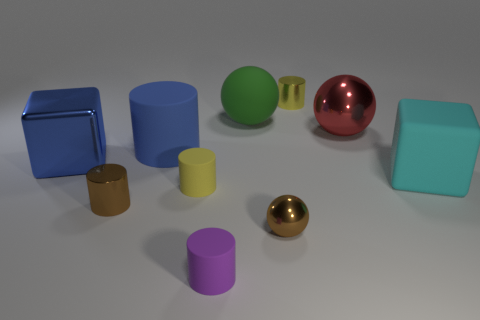Subtract all big blue rubber cylinders. How many cylinders are left? 4 Subtract all blue cylinders. How many cylinders are left? 4 Subtract all green cylinders. Subtract all cyan spheres. How many cylinders are left? 5 Subtract all spheres. How many objects are left? 7 Subtract all yellow rubber cylinders. Subtract all tiny rubber cylinders. How many objects are left? 7 Add 4 large cylinders. How many large cylinders are left? 5 Add 3 big blue objects. How many big blue objects exist? 5 Subtract 0 green cylinders. How many objects are left? 10 